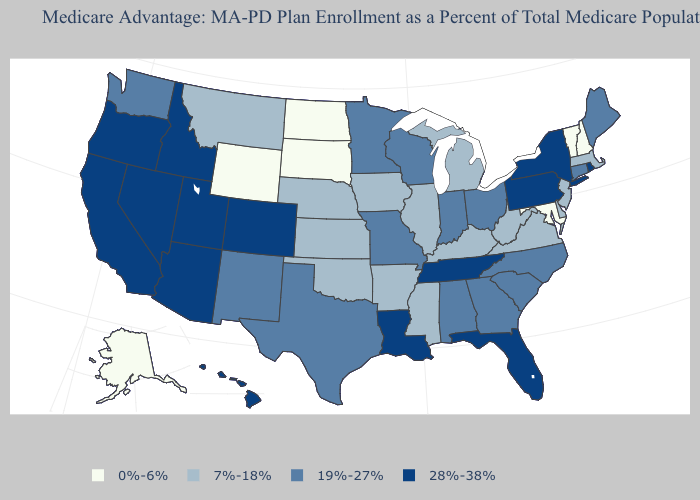What is the highest value in the USA?
Answer briefly. 28%-38%. Name the states that have a value in the range 7%-18%?
Short answer required. Arkansas, Delaware, Iowa, Illinois, Kansas, Kentucky, Massachusetts, Michigan, Mississippi, Montana, Nebraska, New Jersey, Oklahoma, Virginia, West Virginia. What is the highest value in the West ?
Short answer required. 28%-38%. Name the states that have a value in the range 28%-38%?
Keep it brief. Arizona, California, Colorado, Florida, Hawaii, Idaho, Louisiana, Nevada, New York, Oregon, Pennsylvania, Rhode Island, Tennessee, Utah. Name the states that have a value in the range 28%-38%?
Short answer required. Arizona, California, Colorado, Florida, Hawaii, Idaho, Louisiana, Nevada, New York, Oregon, Pennsylvania, Rhode Island, Tennessee, Utah. Does Idaho have a lower value than Vermont?
Answer briefly. No. Does New York have a higher value than West Virginia?
Write a very short answer. Yes. What is the value of Kansas?
Give a very brief answer. 7%-18%. Which states hav the highest value in the South?
Give a very brief answer. Florida, Louisiana, Tennessee. Which states hav the highest value in the South?
Quick response, please. Florida, Louisiana, Tennessee. What is the value of Alabama?
Keep it brief. 19%-27%. Does North Carolina have the lowest value in the South?
Concise answer only. No. Name the states that have a value in the range 19%-27%?
Short answer required. Alabama, Connecticut, Georgia, Indiana, Maine, Minnesota, Missouri, North Carolina, New Mexico, Ohio, South Carolina, Texas, Washington, Wisconsin. Name the states that have a value in the range 19%-27%?
Be succinct. Alabama, Connecticut, Georgia, Indiana, Maine, Minnesota, Missouri, North Carolina, New Mexico, Ohio, South Carolina, Texas, Washington, Wisconsin. Which states hav the highest value in the South?
Give a very brief answer. Florida, Louisiana, Tennessee. 